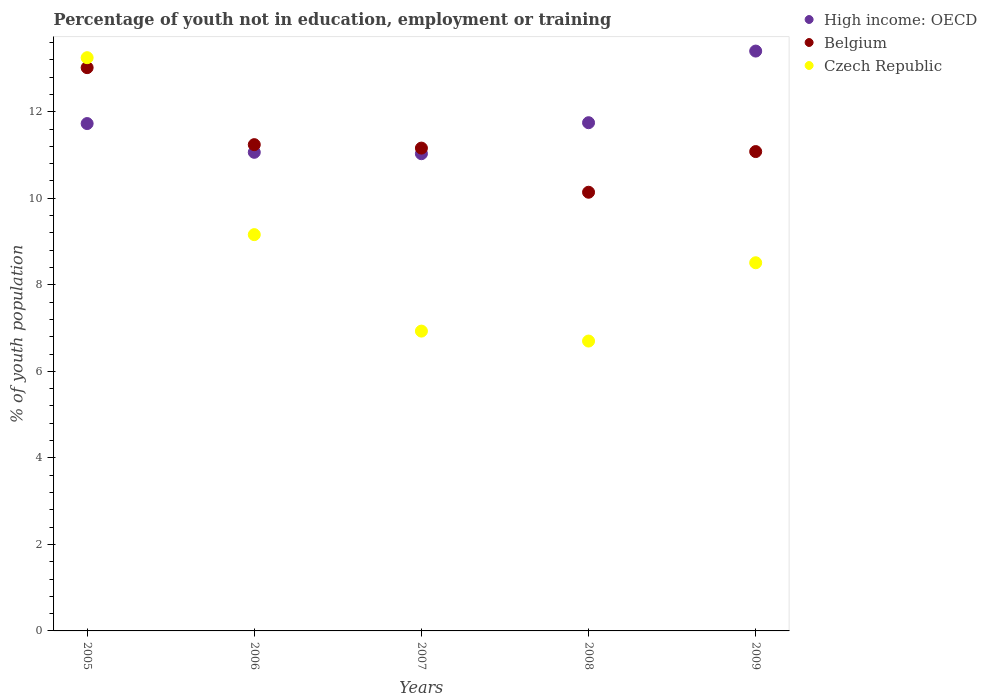How many different coloured dotlines are there?
Give a very brief answer. 3. Is the number of dotlines equal to the number of legend labels?
Your answer should be compact. Yes. What is the percentage of unemployed youth population in in High income: OECD in 2008?
Give a very brief answer. 11.75. Across all years, what is the maximum percentage of unemployed youth population in in Belgium?
Offer a terse response. 13.02. Across all years, what is the minimum percentage of unemployed youth population in in Belgium?
Keep it short and to the point. 10.14. In which year was the percentage of unemployed youth population in in Belgium minimum?
Ensure brevity in your answer.  2008. What is the total percentage of unemployed youth population in in High income: OECD in the graph?
Give a very brief answer. 58.97. What is the difference between the percentage of unemployed youth population in in Czech Republic in 2006 and that in 2009?
Make the answer very short. 0.65. What is the difference between the percentage of unemployed youth population in in High income: OECD in 2006 and the percentage of unemployed youth population in in Belgium in 2008?
Give a very brief answer. 0.92. What is the average percentage of unemployed youth population in in High income: OECD per year?
Your response must be concise. 11.79. In the year 2006, what is the difference between the percentage of unemployed youth population in in Belgium and percentage of unemployed youth population in in High income: OECD?
Provide a short and direct response. 0.18. What is the ratio of the percentage of unemployed youth population in in Belgium in 2006 to that in 2008?
Make the answer very short. 1.11. Is the percentage of unemployed youth population in in Czech Republic in 2005 less than that in 2009?
Make the answer very short. No. What is the difference between the highest and the second highest percentage of unemployed youth population in in Czech Republic?
Offer a terse response. 4.09. What is the difference between the highest and the lowest percentage of unemployed youth population in in Czech Republic?
Your response must be concise. 6.55. Is the percentage of unemployed youth population in in Czech Republic strictly greater than the percentage of unemployed youth population in in High income: OECD over the years?
Provide a succinct answer. No. How many years are there in the graph?
Provide a succinct answer. 5. Does the graph contain grids?
Your answer should be very brief. No. Where does the legend appear in the graph?
Give a very brief answer. Top right. What is the title of the graph?
Provide a succinct answer. Percentage of youth not in education, employment or training. What is the label or title of the Y-axis?
Keep it short and to the point. % of youth population. What is the % of youth population in High income: OECD in 2005?
Keep it short and to the point. 11.73. What is the % of youth population in Belgium in 2005?
Your answer should be compact. 13.02. What is the % of youth population of Czech Republic in 2005?
Provide a short and direct response. 13.25. What is the % of youth population in High income: OECD in 2006?
Ensure brevity in your answer.  11.06. What is the % of youth population in Belgium in 2006?
Ensure brevity in your answer.  11.24. What is the % of youth population of Czech Republic in 2006?
Your answer should be compact. 9.16. What is the % of youth population in High income: OECD in 2007?
Make the answer very short. 11.03. What is the % of youth population in Belgium in 2007?
Your answer should be very brief. 11.16. What is the % of youth population in Czech Republic in 2007?
Provide a short and direct response. 6.93. What is the % of youth population in High income: OECD in 2008?
Your answer should be very brief. 11.75. What is the % of youth population in Belgium in 2008?
Offer a terse response. 10.14. What is the % of youth population of Czech Republic in 2008?
Provide a succinct answer. 6.7. What is the % of youth population in High income: OECD in 2009?
Offer a very short reply. 13.4. What is the % of youth population of Belgium in 2009?
Offer a terse response. 11.08. What is the % of youth population of Czech Republic in 2009?
Make the answer very short. 8.51. Across all years, what is the maximum % of youth population in High income: OECD?
Offer a very short reply. 13.4. Across all years, what is the maximum % of youth population in Belgium?
Your answer should be compact. 13.02. Across all years, what is the maximum % of youth population in Czech Republic?
Provide a short and direct response. 13.25. Across all years, what is the minimum % of youth population of High income: OECD?
Keep it short and to the point. 11.03. Across all years, what is the minimum % of youth population in Belgium?
Provide a short and direct response. 10.14. Across all years, what is the minimum % of youth population of Czech Republic?
Your response must be concise. 6.7. What is the total % of youth population in High income: OECD in the graph?
Provide a short and direct response. 58.97. What is the total % of youth population of Belgium in the graph?
Keep it short and to the point. 56.64. What is the total % of youth population in Czech Republic in the graph?
Your response must be concise. 44.55. What is the difference between the % of youth population of High income: OECD in 2005 and that in 2006?
Keep it short and to the point. 0.66. What is the difference between the % of youth population in Belgium in 2005 and that in 2006?
Provide a succinct answer. 1.78. What is the difference between the % of youth population of Czech Republic in 2005 and that in 2006?
Ensure brevity in your answer.  4.09. What is the difference between the % of youth population in High income: OECD in 2005 and that in 2007?
Your answer should be compact. 0.7. What is the difference between the % of youth population in Belgium in 2005 and that in 2007?
Make the answer very short. 1.86. What is the difference between the % of youth population in Czech Republic in 2005 and that in 2007?
Provide a short and direct response. 6.32. What is the difference between the % of youth population in High income: OECD in 2005 and that in 2008?
Offer a terse response. -0.02. What is the difference between the % of youth population in Belgium in 2005 and that in 2008?
Your answer should be compact. 2.88. What is the difference between the % of youth population in Czech Republic in 2005 and that in 2008?
Keep it short and to the point. 6.55. What is the difference between the % of youth population of High income: OECD in 2005 and that in 2009?
Your answer should be very brief. -1.68. What is the difference between the % of youth population in Belgium in 2005 and that in 2009?
Offer a very short reply. 1.94. What is the difference between the % of youth population in Czech Republic in 2005 and that in 2009?
Provide a short and direct response. 4.74. What is the difference between the % of youth population of High income: OECD in 2006 and that in 2007?
Ensure brevity in your answer.  0.03. What is the difference between the % of youth population of Belgium in 2006 and that in 2007?
Offer a very short reply. 0.08. What is the difference between the % of youth population in Czech Republic in 2006 and that in 2007?
Provide a short and direct response. 2.23. What is the difference between the % of youth population of High income: OECD in 2006 and that in 2008?
Provide a short and direct response. -0.68. What is the difference between the % of youth population in Czech Republic in 2006 and that in 2008?
Keep it short and to the point. 2.46. What is the difference between the % of youth population in High income: OECD in 2006 and that in 2009?
Ensure brevity in your answer.  -2.34. What is the difference between the % of youth population of Belgium in 2006 and that in 2009?
Offer a very short reply. 0.16. What is the difference between the % of youth population of Czech Republic in 2006 and that in 2009?
Make the answer very short. 0.65. What is the difference between the % of youth population of High income: OECD in 2007 and that in 2008?
Offer a very short reply. -0.72. What is the difference between the % of youth population of Belgium in 2007 and that in 2008?
Ensure brevity in your answer.  1.02. What is the difference between the % of youth population of Czech Republic in 2007 and that in 2008?
Your answer should be compact. 0.23. What is the difference between the % of youth population of High income: OECD in 2007 and that in 2009?
Ensure brevity in your answer.  -2.37. What is the difference between the % of youth population of Belgium in 2007 and that in 2009?
Give a very brief answer. 0.08. What is the difference between the % of youth population in Czech Republic in 2007 and that in 2009?
Offer a terse response. -1.58. What is the difference between the % of youth population in High income: OECD in 2008 and that in 2009?
Your response must be concise. -1.66. What is the difference between the % of youth population in Belgium in 2008 and that in 2009?
Your answer should be compact. -0.94. What is the difference between the % of youth population in Czech Republic in 2008 and that in 2009?
Your answer should be very brief. -1.81. What is the difference between the % of youth population of High income: OECD in 2005 and the % of youth population of Belgium in 2006?
Ensure brevity in your answer.  0.49. What is the difference between the % of youth population of High income: OECD in 2005 and the % of youth population of Czech Republic in 2006?
Provide a short and direct response. 2.57. What is the difference between the % of youth population in Belgium in 2005 and the % of youth population in Czech Republic in 2006?
Ensure brevity in your answer.  3.86. What is the difference between the % of youth population of High income: OECD in 2005 and the % of youth population of Belgium in 2007?
Give a very brief answer. 0.57. What is the difference between the % of youth population in High income: OECD in 2005 and the % of youth population in Czech Republic in 2007?
Your answer should be very brief. 4.8. What is the difference between the % of youth population of Belgium in 2005 and the % of youth population of Czech Republic in 2007?
Your response must be concise. 6.09. What is the difference between the % of youth population of High income: OECD in 2005 and the % of youth population of Belgium in 2008?
Offer a very short reply. 1.59. What is the difference between the % of youth population in High income: OECD in 2005 and the % of youth population in Czech Republic in 2008?
Your answer should be very brief. 5.03. What is the difference between the % of youth population in Belgium in 2005 and the % of youth population in Czech Republic in 2008?
Give a very brief answer. 6.32. What is the difference between the % of youth population of High income: OECD in 2005 and the % of youth population of Belgium in 2009?
Offer a terse response. 0.65. What is the difference between the % of youth population of High income: OECD in 2005 and the % of youth population of Czech Republic in 2009?
Your answer should be very brief. 3.22. What is the difference between the % of youth population in Belgium in 2005 and the % of youth population in Czech Republic in 2009?
Your answer should be very brief. 4.51. What is the difference between the % of youth population of High income: OECD in 2006 and the % of youth population of Belgium in 2007?
Provide a short and direct response. -0.1. What is the difference between the % of youth population in High income: OECD in 2006 and the % of youth population in Czech Republic in 2007?
Your answer should be very brief. 4.13. What is the difference between the % of youth population in Belgium in 2006 and the % of youth population in Czech Republic in 2007?
Offer a very short reply. 4.31. What is the difference between the % of youth population in High income: OECD in 2006 and the % of youth population in Belgium in 2008?
Your answer should be compact. 0.92. What is the difference between the % of youth population of High income: OECD in 2006 and the % of youth population of Czech Republic in 2008?
Provide a succinct answer. 4.36. What is the difference between the % of youth population of Belgium in 2006 and the % of youth population of Czech Republic in 2008?
Ensure brevity in your answer.  4.54. What is the difference between the % of youth population in High income: OECD in 2006 and the % of youth population in Belgium in 2009?
Give a very brief answer. -0.02. What is the difference between the % of youth population in High income: OECD in 2006 and the % of youth population in Czech Republic in 2009?
Keep it short and to the point. 2.55. What is the difference between the % of youth population of Belgium in 2006 and the % of youth population of Czech Republic in 2009?
Provide a succinct answer. 2.73. What is the difference between the % of youth population in High income: OECD in 2007 and the % of youth population in Belgium in 2008?
Make the answer very short. 0.89. What is the difference between the % of youth population in High income: OECD in 2007 and the % of youth population in Czech Republic in 2008?
Your response must be concise. 4.33. What is the difference between the % of youth population of Belgium in 2007 and the % of youth population of Czech Republic in 2008?
Give a very brief answer. 4.46. What is the difference between the % of youth population of High income: OECD in 2007 and the % of youth population of Belgium in 2009?
Provide a succinct answer. -0.05. What is the difference between the % of youth population of High income: OECD in 2007 and the % of youth population of Czech Republic in 2009?
Offer a terse response. 2.52. What is the difference between the % of youth population in Belgium in 2007 and the % of youth population in Czech Republic in 2009?
Offer a terse response. 2.65. What is the difference between the % of youth population of High income: OECD in 2008 and the % of youth population of Belgium in 2009?
Offer a terse response. 0.67. What is the difference between the % of youth population in High income: OECD in 2008 and the % of youth population in Czech Republic in 2009?
Offer a terse response. 3.24. What is the difference between the % of youth population in Belgium in 2008 and the % of youth population in Czech Republic in 2009?
Provide a succinct answer. 1.63. What is the average % of youth population in High income: OECD per year?
Offer a very short reply. 11.79. What is the average % of youth population of Belgium per year?
Give a very brief answer. 11.33. What is the average % of youth population in Czech Republic per year?
Keep it short and to the point. 8.91. In the year 2005, what is the difference between the % of youth population in High income: OECD and % of youth population in Belgium?
Your answer should be compact. -1.29. In the year 2005, what is the difference between the % of youth population in High income: OECD and % of youth population in Czech Republic?
Your answer should be very brief. -1.52. In the year 2005, what is the difference between the % of youth population of Belgium and % of youth population of Czech Republic?
Give a very brief answer. -0.23. In the year 2006, what is the difference between the % of youth population in High income: OECD and % of youth population in Belgium?
Provide a short and direct response. -0.18. In the year 2006, what is the difference between the % of youth population in High income: OECD and % of youth population in Czech Republic?
Give a very brief answer. 1.9. In the year 2006, what is the difference between the % of youth population of Belgium and % of youth population of Czech Republic?
Your response must be concise. 2.08. In the year 2007, what is the difference between the % of youth population in High income: OECD and % of youth population in Belgium?
Provide a short and direct response. -0.13. In the year 2007, what is the difference between the % of youth population in High income: OECD and % of youth population in Czech Republic?
Give a very brief answer. 4.1. In the year 2007, what is the difference between the % of youth population of Belgium and % of youth population of Czech Republic?
Provide a short and direct response. 4.23. In the year 2008, what is the difference between the % of youth population in High income: OECD and % of youth population in Belgium?
Give a very brief answer. 1.61. In the year 2008, what is the difference between the % of youth population in High income: OECD and % of youth population in Czech Republic?
Provide a succinct answer. 5.05. In the year 2008, what is the difference between the % of youth population of Belgium and % of youth population of Czech Republic?
Keep it short and to the point. 3.44. In the year 2009, what is the difference between the % of youth population of High income: OECD and % of youth population of Belgium?
Provide a short and direct response. 2.32. In the year 2009, what is the difference between the % of youth population in High income: OECD and % of youth population in Czech Republic?
Your answer should be compact. 4.89. In the year 2009, what is the difference between the % of youth population in Belgium and % of youth population in Czech Republic?
Ensure brevity in your answer.  2.57. What is the ratio of the % of youth population in High income: OECD in 2005 to that in 2006?
Provide a short and direct response. 1.06. What is the ratio of the % of youth population in Belgium in 2005 to that in 2006?
Offer a very short reply. 1.16. What is the ratio of the % of youth population in Czech Republic in 2005 to that in 2006?
Offer a very short reply. 1.45. What is the ratio of the % of youth population in High income: OECD in 2005 to that in 2007?
Make the answer very short. 1.06. What is the ratio of the % of youth population in Czech Republic in 2005 to that in 2007?
Ensure brevity in your answer.  1.91. What is the ratio of the % of youth population of High income: OECD in 2005 to that in 2008?
Provide a short and direct response. 1. What is the ratio of the % of youth population of Belgium in 2005 to that in 2008?
Offer a very short reply. 1.28. What is the ratio of the % of youth population of Czech Republic in 2005 to that in 2008?
Keep it short and to the point. 1.98. What is the ratio of the % of youth population in High income: OECD in 2005 to that in 2009?
Ensure brevity in your answer.  0.88. What is the ratio of the % of youth population of Belgium in 2005 to that in 2009?
Ensure brevity in your answer.  1.18. What is the ratio of the % of youth population of Czech Republic in 2005 to that in 2009?
Give a very brief answer. 1.56. What is the ratio of the % of youth population of Czech Republic in 2006 to that in 2007?
Your answer should be very brief. 1.32. What is the ratio of the % of youth population in High income: OECD in 2006 to that in 2008?
Offer a terse response. 0.94. What is the ratio of the % of youth population of Belgium in 2006 to that in 2008?
Offer a terse response. 1.11. What is the ratio of the % of youth population of Czech Republic in 2006 to that in 2008?
Your response must be concise. 1.37. What is the ratio of the % of youth population of High income: OECD in 2006 to that in 2009?
Your response must be concise. 0.83. What is the ratio of the % of youth population of Belgium in 2006 to that in 2009?
Keep it short and to the point. 1.01. What is the ratio of the % of youth population of Czech Republic in 2006 to that in 2009?
Offer a very short reply. 1.08. What is the ratio of the % of youth population of High income: OECD in 2007 to that in 2008?
Offer a very short reply. 0.94. What is the ratio of the % of youth population of Belgium in 2007 to that in 2008?
Offer a terse response. 1.1. What is the ratio of the % of youth population of Czech Republic in 2007 to that in 2008?
Offer a very short reply. 1.03. What is the ratio of the % of youth population in High income: OECD in 2007 to that in 2009?
Ensure brevity in your answer.  0.82. What is the ratio of the % of youth population in Czech Republic in 2007 to that in 2009?
Ensure brevity in your answer.  0.81. What is the ratio of the % of youth population of High income: OECD in 2008 to that in 2009?
Offer a very short reply. 0.88. What is the ratio of the % of youth population in Belgium in 2008 to that in 2009?
Your answer should be compact. 0.92. What is the ratio of the % of youth population in Czech Republic in 2008 to that in 2009?
Ensure brevity in your answer.  0.79. What is the difference between the highest and the second highest % of youth population of High income: OECD?
Offer a terse response. 1.66. What is the difference between the highest and the second highest % of youth population of Belgium?
Provide a short and direct response. 1.78. What is the difference between the highest and the second highest % of youth population in Czech Republic?
Offer a very short reply. 4.09. What is the difference between the highest and the lowest % of youth population of High income: OECD?
Provide a succinct answer. 2.37. What is the difference between the highest and the lowest % of youth population in Belgium?
Your answer should be compact. 2.88. What is the difference between the highest and the lowest % of youth population in Czech Republic?
Your answer should be very brief. 6.55. 